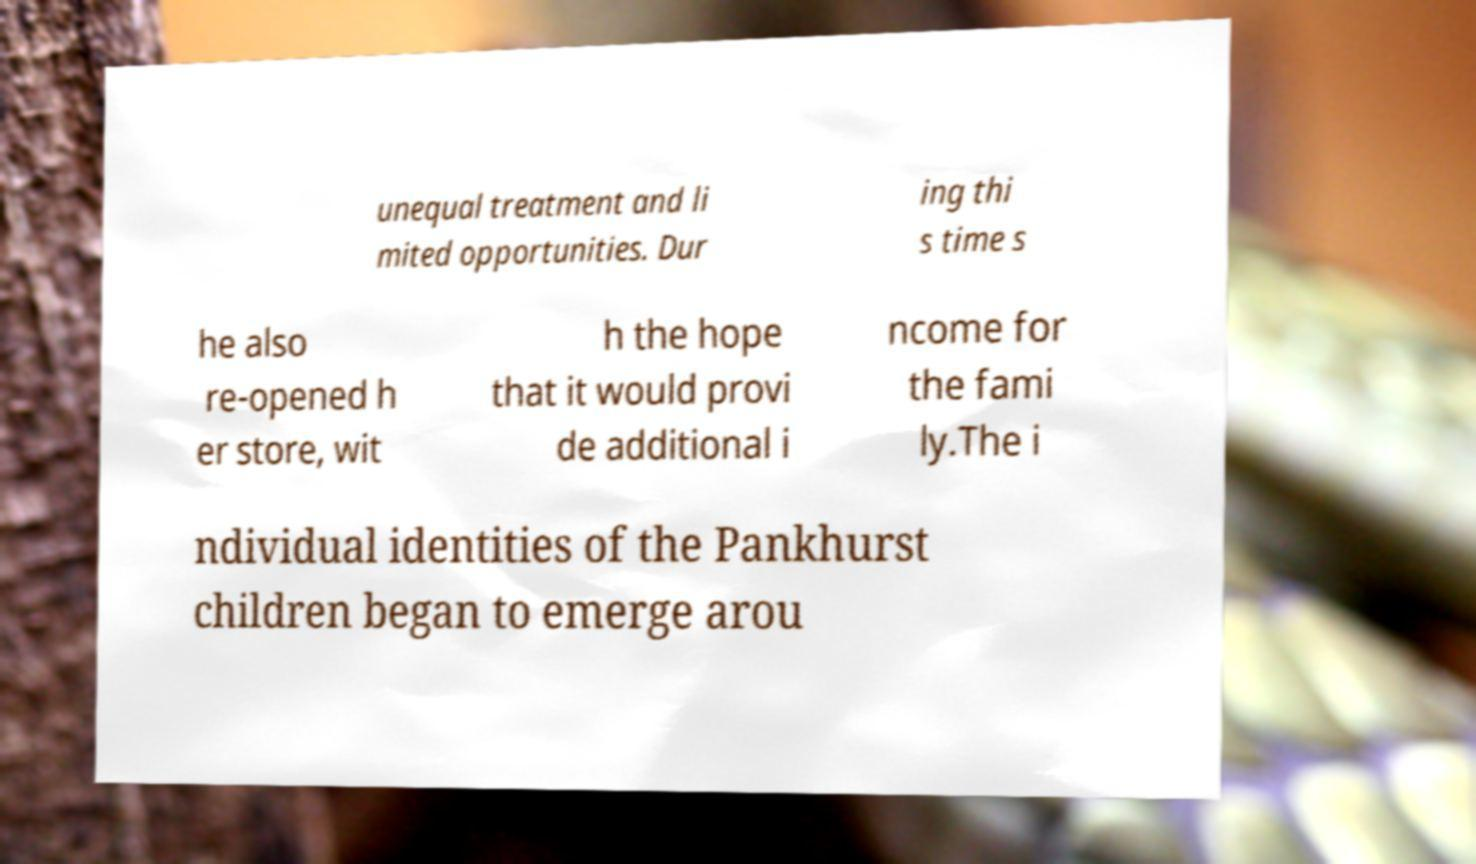I need the written content from this picture converted into text. Can you do that? unequal treatment and li mited opportunities. Dur ing thi s time s he also re-opened h er store, wit h the hope that it would provi de additional i ncome for the fami ly.The i ndividual identities of the Pankhurst children began to emerge arou 